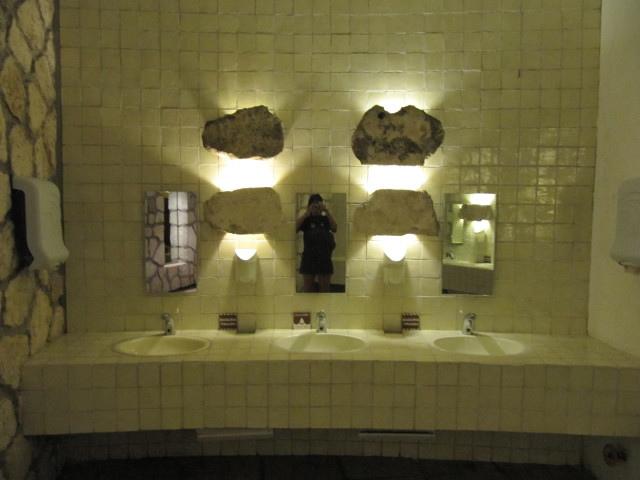How many sinks are in the bathroom?
Quick response, please. 3. What is the sink counter made of?
Be succinct. Tile. Are there any mirrors in this photo?
Write a very short answer. Yes. What type of stone is being worked?
Short answer required. Granite. 